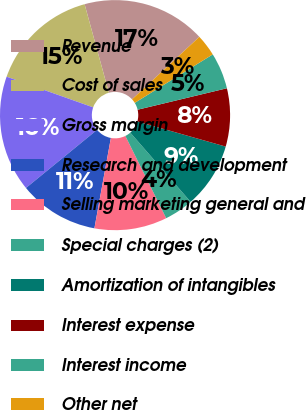Convert chart to OTSL. <chart><loc_0><loc_0><loc_500><loc_500><pie_chart><fcel>Revenue<fcel>Cost of sales<fcel>Gross margin<fcel>Research and development<fcel>Selling marketing general and<fcel>Special charges (2)<fcel>Amortization of intangibles<fcel>Interest expense<fcel>Interest income<fcel>Other net<nl><fcel>17.35%<fcel>15.31%<fcel>16.33%<fcel>11.22%<fcel>10.2%<fcel>4.08%<fcel>9.18%<fcel>8.16%<fcel>5.1%<fcel>3.06%<nl></chart> 